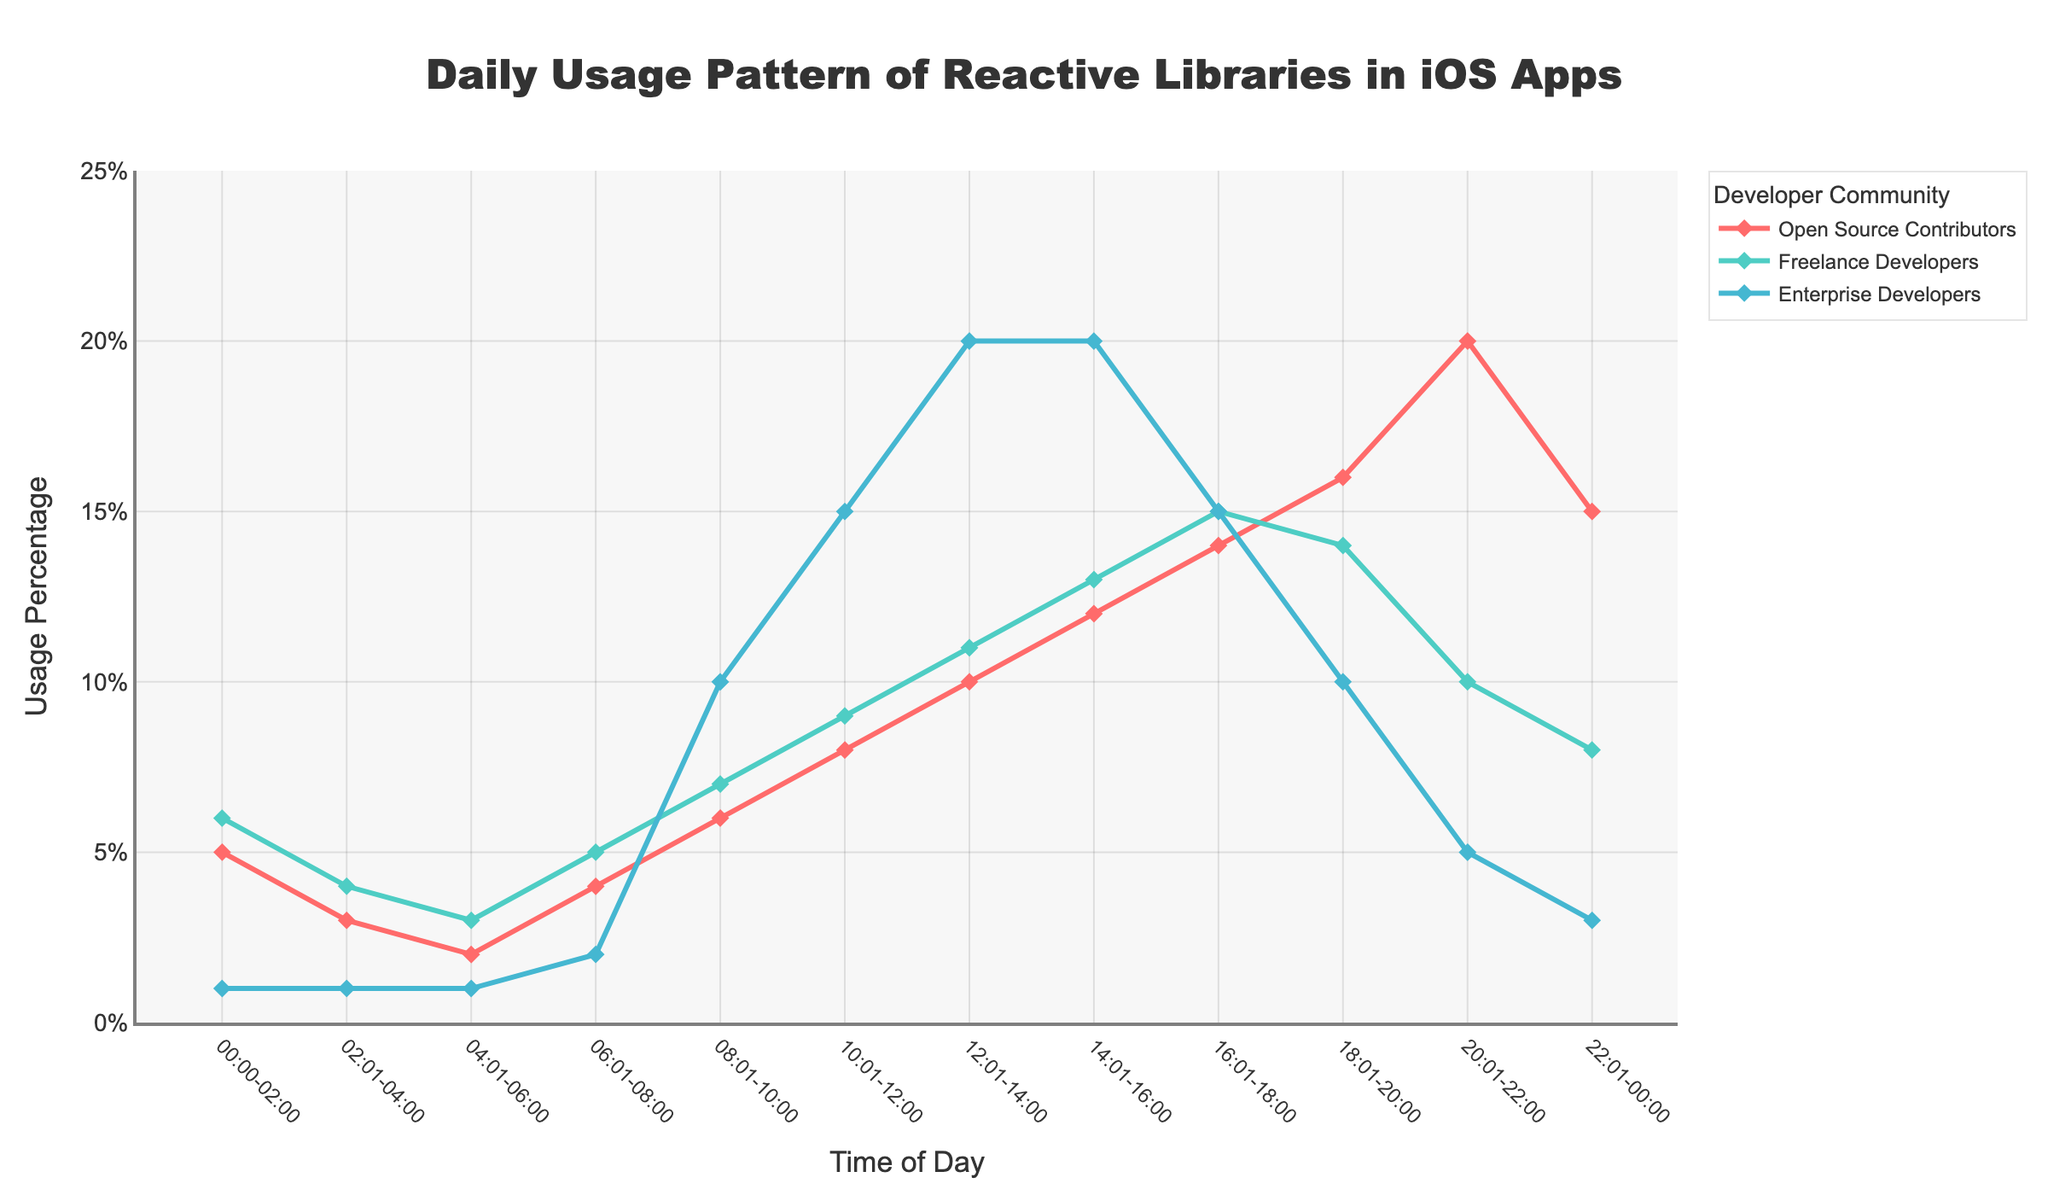What is the title of the plot? The title is typically located at the top of the plot and summarizes the main subject of the plot. In this case, the title is "Daily Usage Pattern of Reactive Libraries in iOS Apps," which is clearly visible at the top.
Answer: Daily Usage Pattern of Reactive Libraries in iOS Apps Which developer community has the highest usage percentage between 20:01 and 22:00? Looking at the lines corresponding to each community at the time interval 20:01-22:00, the highest point is for Open Source Contributors with 20%.
Answer: Open Source Contributors What is the usage percentage for Freelance Developers at 06:01-08:00? Locate the line for Freelance Developers and find the data point at the time interval 06:01-08:00. The corresponding usage percentage is 5%.
Answer: 5% During which time interval is the usage percentage for Enterprise Developers the highest? For the Enterprise Developers' line, the highest point is at two intervals, 12:01-14:00 and 14:01-16:00, both at 20%.
Answer: 12:01-14:00 and 14:01-16:00 What is the difference in usage percentage between 18:01-20:00 and 20:01-22:00 for Open Source Contributors? For Open Source Contributors, the usage percentage is 16% between 18:01-20:00 and 20% between 20:01-22:00. The difference is 20% - 16% = 4%.
Answer: 4% Which developer community shows a decrease in usage percentage after 20:01-22:00? Looking at the lines after the 20:01-22:00 point, the only community with a decrease in usage percentage is Open Source Contributors, which goes from 20% to 15%.
Answer: Open Source Contributors How does the usage pattern of Freelance Developers compare to Enterprise Developers between 10:01 and 14:00? Between the time intervals 10:01-14:00, Freelance Developers' usage percentages are 9% and 11%, while Enterprise Developers' are 15% and 20%. Enterprise Developers' usage is higher during this period.
Answer: Enterprise Developers' usage is higher What time interval has the equal usage percentage for both Open Source Contributors and Freelance Developers? Identify where the lines for Open Source Contributors and Freelance Developers intersect. Both have a usage percentage of 14% at 16:01-18:00.
Answer: 16:01-18:00 What is the total usage percentage for Open Source Contributors across all time intervals? Sum the usage percentages for Open Source Contributors across all intervals: 5 + 3 + 2 + 4 + 6 + 8 + 10 + 12 + 14 + 16 + 20 + 15 = 115%.
Answer: 115% 